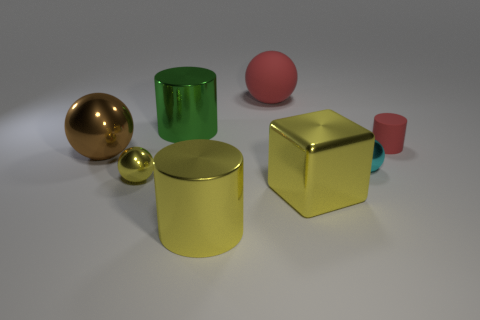Are there any brown objects of the same size as the yellow cube?
Make the answer very short. Yes. Are there fewer large purple cylinders than green metal cylinders?
Give a very brief answer. Yes. How many cylinders are either tiny purple matte objects or big yellow objects?
Ensure brevity in your answer.  1. What number of metal balls are the same color as the shiny block?
Provide a short and direct response. 1. What size is the metal ball that is to the left of the big red matte sphere and in front of the large brown shiny sphere?
Offer a very short reply. Small. Is the number of small cylinders in front of the yellow metal cube less than the number of small cyan things?
Your answer should be compact. Yes. Does the large yellow block have the same material as the green object?
Ensure brevity in your answer.  Yes. How many things are big metal objects or cyan metallic balls?
Provide a short and direct response. 5. How many big cyan cubes are the same material as the big yellow block?
Provide a short and direct response. 0. What is the size of the red thing that is the same shape as the small cyan thing?
Make the answer very short. Large. 